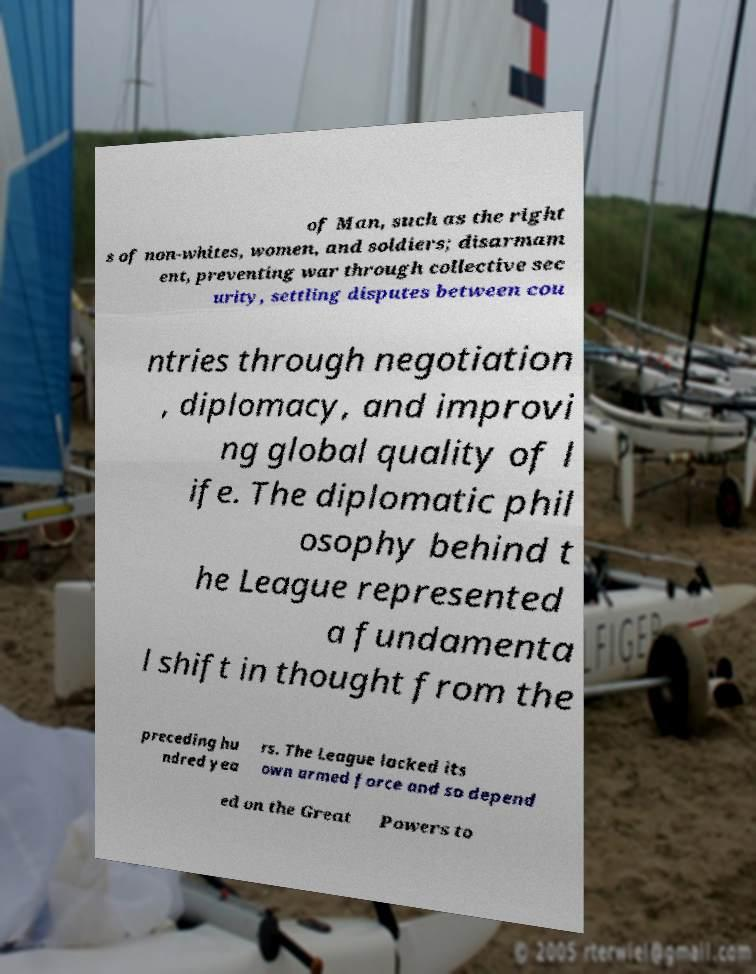Could you assist in decoding the text presented in this image and type it out clearly? of Man, such as the right s of non-whites, women, and soldiers; disarmam ent, preventing war through collective sec urity, settling disputes between cou ntries through negotiation , diplomacy, and improvi ng global quality of l ife. The diplomatic phil osophy behind t he League represented a fundamenta l shift in thought from the preceding hu ndred yea rs. The League lacked its own armed force and so depend ed on the Great Powers to 